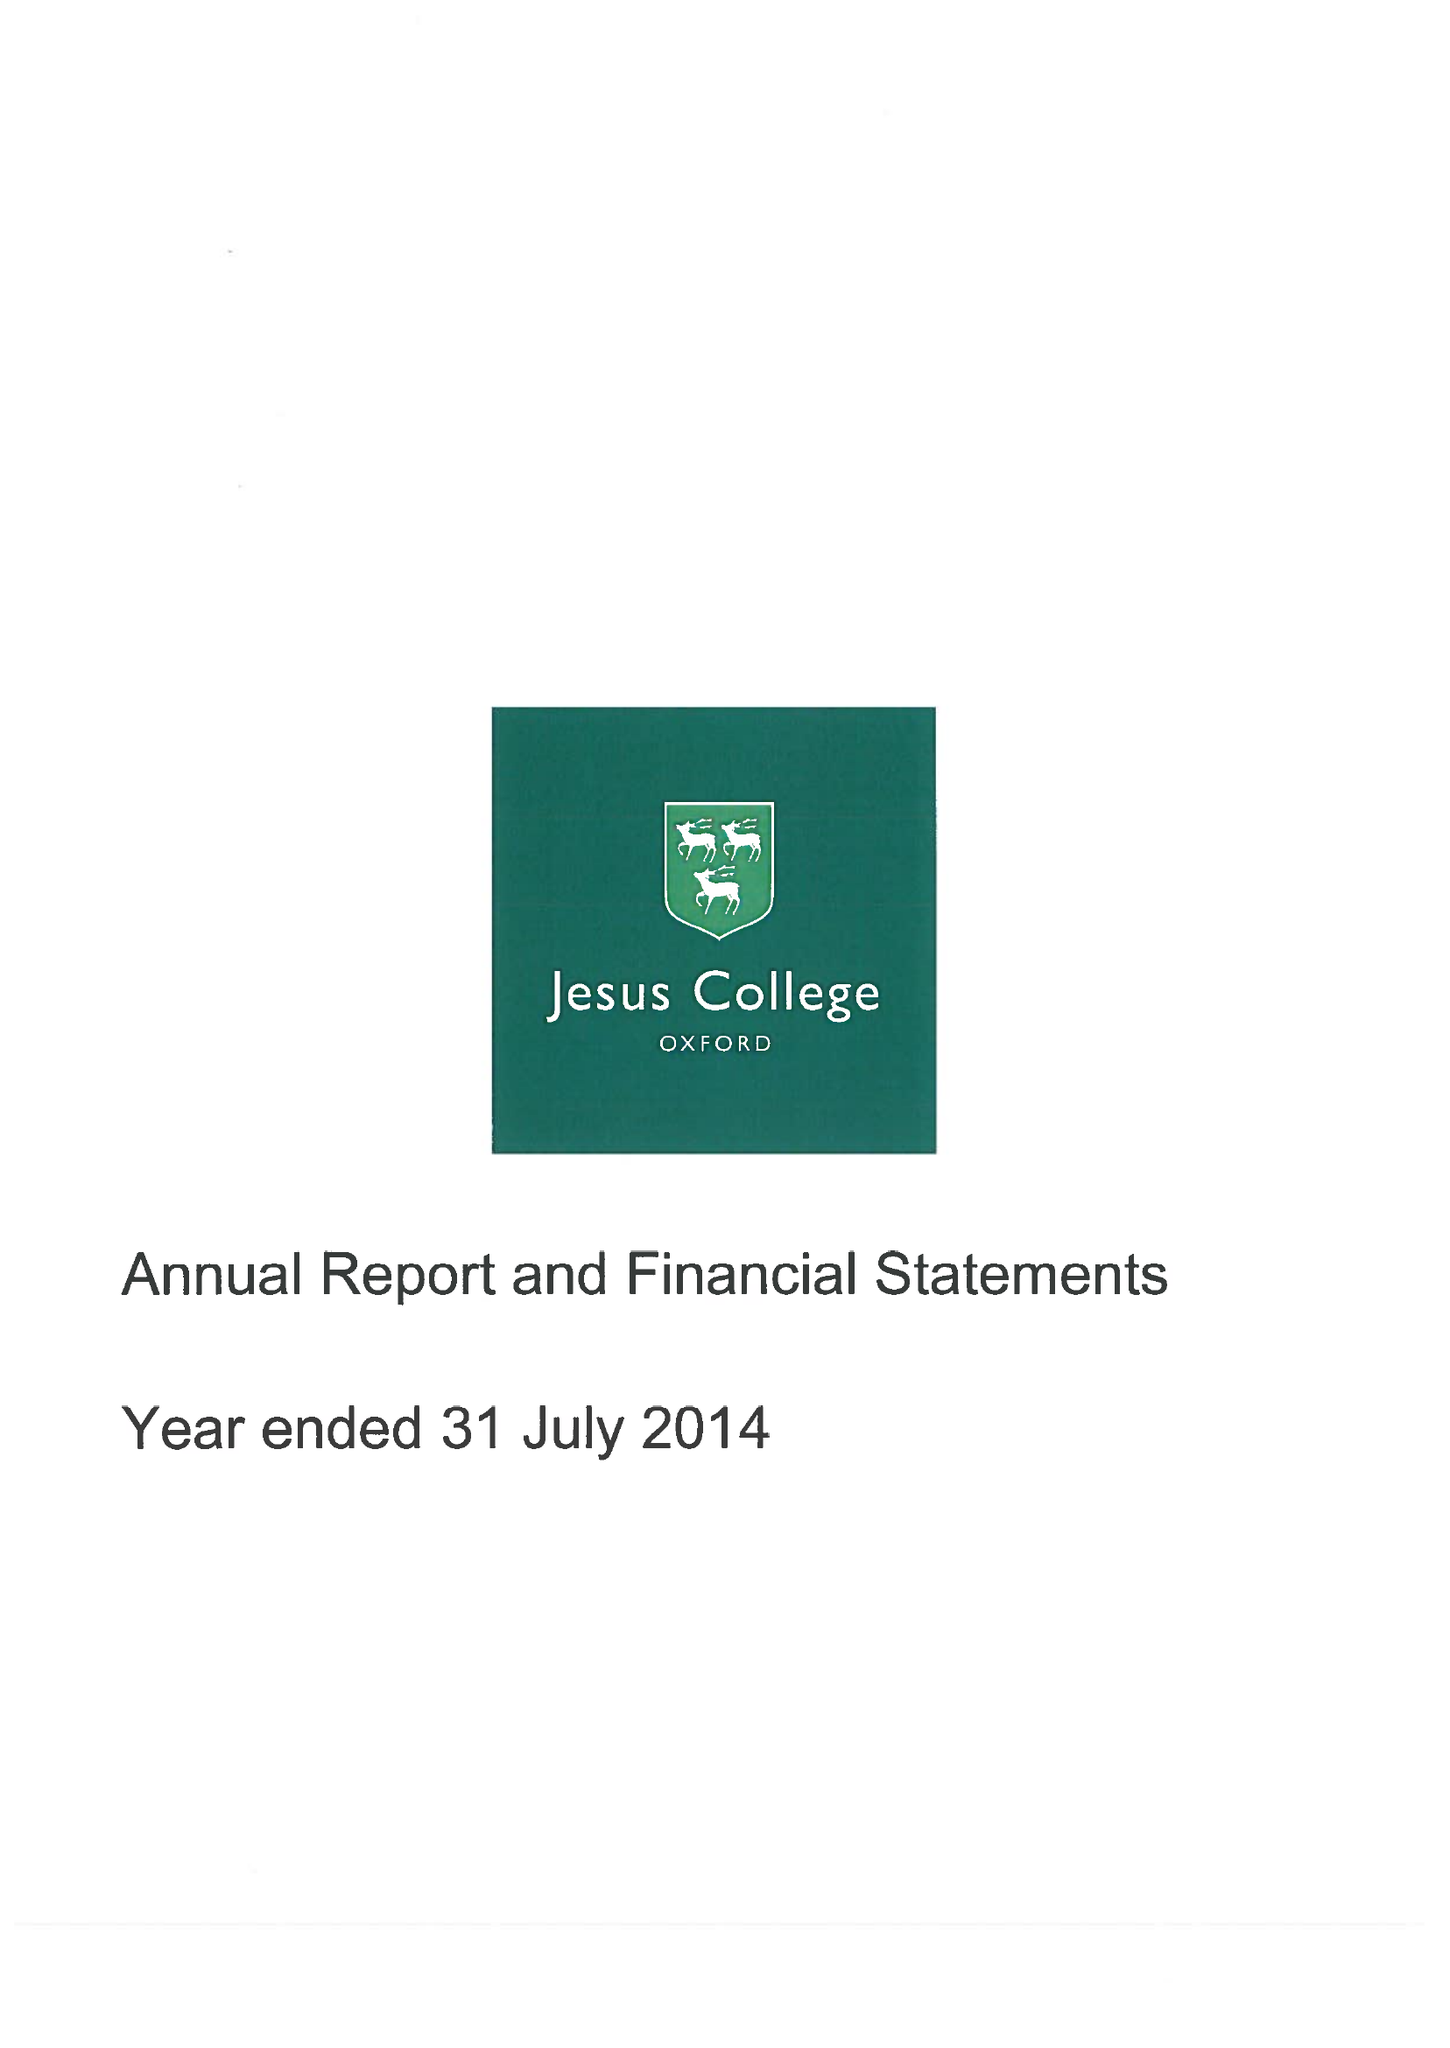What is the value for the address__postcode?
Answer the question using a single word or phrase. OX1 3DW 